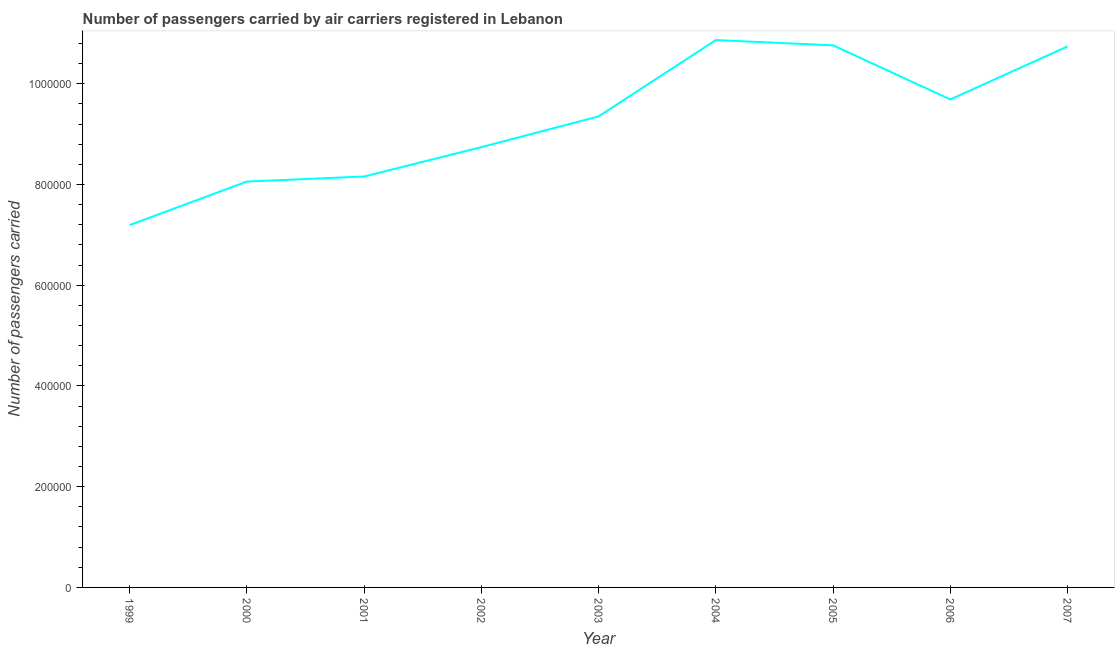What is the number of passengers carried in 2003?
Ensure brevity in your answer.  9.35e+05. Across all years, what is the maximum number of passengers carried?
Offer a terse response. 1.09e+06. Across all years, what is the minimum number of passengers carried?
Ensure brevity in your answer.  7.19e+05. In which year was the number of passengers carried maximum?
Your answer should be very brief. 2004. In which year was the number of passengers carried minimum?
Give a very brief answer. 1999. What is the sum of the number of passengers carried?
Make the answer very short. 8.36e+06. What is the difference between the number of passengers carried in 2006 and 2007?
Ensure brevity in your answer.  -1.05e+05. What is the average number of passengers carried per year?
Your response must be concise. 9.28e+05. What is the median number of passengers carried?
Offer a very short reply. 9.35e+05. In how many years, is the number of passengers carried greater than 1000000 ?
Offer a very short reply. 3. What is the ratio of the number of passengers carried in 2001 to that in 2006?
Offer a terse response. 0.84. Is the number of passengers carried in 2002 less than that in 2004?
Provide a short and direct response. Yes. Is the difference between the number of passengers carried in 2001 and 2004 greater than the difference between any two years?
Make the answer very short. No. What is the difference between the highest and the second highest number of passengers carried?
Offer a terse response. 1.05e+04. What is the difference between the highest and the lowest number of passengers carried?
Provide a succinct answer. 3.67e+05. Does the number of passengers carried monotonically increase over the years?
Provide a short and direct response. No. How many years are there in the graph?
Your response must be concise. 9. What is the title of the graph?
Provide a short and direct response. Number of passengers carried by air carriers registered in Lebanon. What is the label or title of the Y-axis?
Your answer should be very brief. Number of passengers carried. What is the Number of passengers carried of 1999?
Your answer should be very brief. 7.19e+05. What is the Number of passengers carried of 2000?
Your answer should be very brief. 8.06e+05. What is the Number of passengers carried in 2001?
Make the answer very short. 8.16e+05. What is the Number of passengers carried of 2002?
Ensure brevity in your answer.  8.74e+05. What is the Number of passengers carried of 2003?
Your response must be concise. 9.35e+05. What is the Number of passengers carried in 2004?
Your answer should be compact. 1.09e+06. What is the Number of passengers carried in 2005?
Offer a terse response. 1.08e+06. What is the Number of passengers carried in 2006?
Provide a short and direct response. 9.69e+05. What is the Number of passengers carried in 2007?
Provide a short and direct response. 1.07e+06. What is the difference between the Number of passengers carried in 1999 and 2000?
Your response must be concise. -8.64e+04. What is the difference between the Number of passengers carried in 1999 and 2001?
Provide a succinct answer. -9.65e+04. What is the difference between the Number of passengers carried in 1999 and 2002?
Your response must be concise. -1.55e+05. What is the difference between the Number of passengers carried in 1999 and 2003?
Offer a very short reply. -2.16e+05. What is the difference between the Number of passengers carried in 1999 and 2004?
Provide a short and direct response. -3.67e+05. What is the difference between the Number of passengers carried in 1999 and 2005?
Provide a short and direct response. -3.57e+05. What is the difference between the Number of passengers carried in 1999 and 2006?
Provide a succinct answer. -2.49e+05. What is the difference between the Number of passengers carried in 1999 and 2007?
Keep it short and to the point. -3.55e+05. What is the difference between the Number of passengers carried in 2000 and 2001?
Offer a terse response. -1.01e+04. What is the difference between the Number of passengers carried in 2000 and 2002?
Ensure brevity in your answer.  -6.83e+04. What is the difference between the Number of passengers carried in 2000 and 2003?
Keep it short and to the point. -1.29e+05. What is the difference between the Number of passengers carried in 2000 and 2004?
Your response must be concise. -2.81e+05. What is the difference between the Number of passengers carried in 2000 and 2005?
Your response must be concise. -2.70e+05. What is the difference between the Number of passengers carried in 2000 and 2006?
Provide a short and direct response. -1.63e+05. What is the difference between the Number of passengers carried in 2000 and 2007?
Your answer should be very brief. -2.68e+05. What is the difference between the Number of passengers carried in 2001 and 2002?
Ensure brevity in your answer.  -5.83e+04. What is the difference between the Number of passengers carried in 2001 and 2003?
Your response must be concise. -1.19e+05. What is the difference between the Number of passengers carried in 2001 and 2004?
Make the answer very short. -2.71e+05. What is the difference between the Number of passengers carried in 2001 and 2005?
Make the answer very short. -2.60e+05. What is the difference between the Number of passengers carried in 2001 and 2006?
Give a very brief answer. -1.53e+05. What is the difference between the Number of passengers carried in 2001 and 2007?
Your answer should be compact. -2.58e+05. What is the difference between the Number of passengers carried in 2002 and 2003?
Provide a succinct answer. -6.11e+04. What is the difference between the Number of passengers carried in 2002 and 2004?
Provide a short and direct response. -2.13e+05. What is the difference between the Number of passengers carried in 2002 and 2005?
Offer a very short reply. -2.02e+05. What is the difference between the Number of passengers carried in 2002 and 2006?
Offer a terse response. -9.47e+04. What is the difference between the Number of passengers carried in 2002 and 2007?
Your answer should be compact. -2.00e+05. What is the difference between the Number of passengers carried in 2003 and 2004?
Give a very brief answer. -1.52e+05. What is the difference between the Number of passengers carried in 2003 and 2005?
Make the answer very short. -1.41e+05. What is the difference between the Number of passengers carried in 2003 and 2006?
Your response must be concise. -3.36e+04. What is the difference between the Number of passengers carried in 2003 and 2007?
Offer a very short reply. -1.39e+05. What is the difference between the Number of passengers carried in 2004 and 2005?
Offer a very short reply. 1.05e+04. What is the difference between the Number of passengers carried in 2004 and 2006?
Provide a short and direct response. 1.18e+05. What is the difference between the Number of passengers carried in 2004 and 2007?
Ensure brevity in your answer.  1.25e+04. What is the difference between the Number of passengers carried in 2005 and 2006?
Give a very brief answer. 1.07e+05. What is the difference between the Number of passengers carried in 2005 and 2007?
Your response must be concise. 2039. What is the difference between the Number of passengers carried in 2006 and 2007?
Make the answer very short. -1.05e+05. What is the ratio of the Number of passengers carried in 1999 to that in 2000?
Your response must be concise. 0.89. What is the ratio of the Number of passengers carried in 1999 to that in 2001?
Your response must be concise. 0.88. What is the ratio of the Number of passengers carried in 1999 to that in 2002?
Make the answer very short. 0.82. What is the ratio of the Number of passengers carried in 1999 to that in 2003?
Provide a succinct answer. 0.77. What is the ratio of the Number of passengers carried in 1999 to that in 2004?
Your answer should be very brief. 0.66. What is the ratio of the Number of passengers carried in 1999 to that in 2005?
Ensure brevity in your answer.  0.67. What is the ratio of the Number of passengers carried in 1999 to that in 2006?
Give a very brief answer. 0.74. What is the ratio of the Number of passengers carried in 1999 to that in 2007?
Provide a succinct answer. 0.67. What is the ratio of the Number of passengers carried in 2000 to that in 2001?
Provide a succinct answer. 0.99. What is the ratio of the Number of passengers carried in 2000 to that in 2002?
Your answer should be very brief. 0.92. What is the ratio of the Number of passengers carried in 2000 to that in 2003?
Offer a terse response. 0.86. What is the ratio of the Number of passengers carried in 2000 to that in 2004?
Provide a succinct answer. 0.74. What is the ratio of the Number of passengers carried in 2000 to that in 2005?
Your answer should be compact. 0.75. What is the ratio of the Number of passengers carried in 2000 to that in 2006?
Your answer should be compact. 0.83. What is the ratio of the Number of passengers carried in 2001 to that in 2002?
Keep it short and to the point. 0.93. What is the ratio of the Number of passengers carried in 2001 to that in 2003?
Give a very brief answer. 0.87. What is the ratio of the Number of passengers carried in 2001 to that in 2004?
Ensure brevity in your answer.  0.75. What is the ratio of the Number of passengers carried in 2001 to that in 2005?
Make the answer very short. 0.76. What is the ratio of the Number of passengers carried in 2001 to that in 2006?
Your answer should be very brief. 0.84. What is the ratio of the Number of passengers carried in 2001 to that in 2007?
Make the answer very short. 0.76. What is the ratio of the Number of passengers carried in 2002 to that in 2003?
Give a very brief answer. 0.94. What is the ratio of the Number of passengers carried in 2002 to that in 2004?
Keep it short and to the point. 0.8. What is the ratio of the Number of passengers carried in 2002 to that in 2005?
Your response must be concise. 0.81. What is the ratio of the Number of passengers carried in 2002 to that in 2006?
Give a very brief answer. 0.9. What is the ratio of the Number of passengers carried in 2002 to that in 2007?
Offer a terse response. 0.81. What is the ratio of the Number of passengers carried in 2003 to that in 2004?
Provide a short and direct response. 0.86. What is the ratio of the Number of passengers carried in 2003 to that in 2005?
Provide a short and direct response. 0.87. What is the ratio of the Number of passengers carried in 2003 to that in 2006?
Offer a terse response. 0.96. What is the ratio of the Number of passengers carried in 2003 to that in 2007?
Your answer should be compact. 0.87. What is the ratio of the Number of passengers carried in 2004 to that in 2005?
Provide a succinct answer. 1.01. What is the ratio of the Number of passengers carried in 2004 to that in 2006?
Offer a very short reply. 1.12. What is the ratio of the Number of passengers carried in 2004 to that in 2007?
Ensure brevity in your answer.  1.01. What is the ratio of the Number of passengers carried in 2005 to that in 2006?
Your answer should be compact. 1.11. What is the ratio of the Number of passengers carried in 2006 to that in 2007?
Provide a succinct answer. 0.9. 